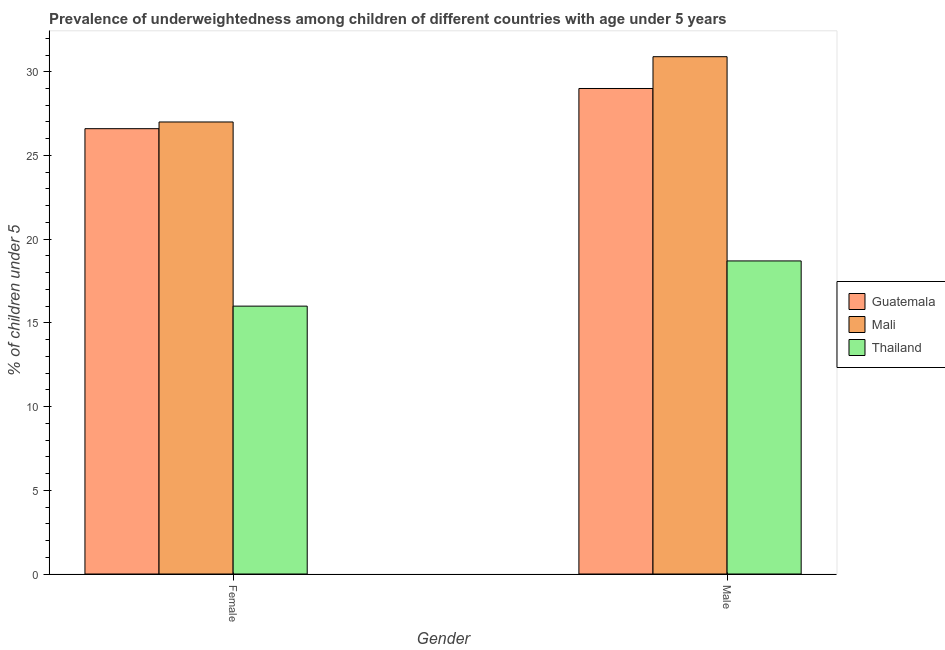How many different coloured bars are there?
Offer a terse response. 3. How many bars are there on the 1st tick from the left?
Provide a short and direct response. 3. How many bars are there on the 1st tick from the right?
Your answer should be very brief. 3. What is the label of the 2nd group of bars from the left?
Keep it short and to the point. Male. What is the percentage of underweighted female children in Mali?
Keep it short and to the point. 27. Across all countries, what is the minimum percentage of underweighted male children?
Keep it short and to the point. 18.7. In which country was the percentage of underweighted female children maximum?
Keep it short and to the point. Mali. In which country was the percentage of underweighted male children minimum?
Give a very brief answer. Thailand. What is the total percentage of underweighted male children in the graph?
Offer a very short reply. 78.6. What is the difference between the percentage of underweighted female children in Thailand and that in Guatemala?
Keep it short and to the point. -10.6. What is the difference between the percentage of underweighted male children in Thailand and the percentage of underweighted female children in Guatemala?
Your answer should be compact. -7.9. What is the average percentage of underweighted female children per country?
Your answer should be very brief. 23.2. What is the difference between the percentage of underweighted male children and percentage of underweighted female children in Mali?
Your answer should be very brief. 3.9. In how many countries, is the percentage of underweighted female children greater than 8 %?
Offer a very short reply. 3. What is the ratio of the percentage of underweighted male children in Mali to that in Guatemala?
Offer a very short reply. 1.07. Is the percentage of underweighted male children in Guatemala less than that in Mali?
Give a very brief answer. Yes. In how many countries, is the percentage of underweighted male children greater than the average percentage of underweighted male children taken over all countries?
Make the answer very short. 2. What does the 2nd bar from the left in Female represents?
Offer a terse response. Mali. What does the 1st bar from the right in Male represents?
Provide a succinct answer. Thailand. How many bars are there?
Your answer should be very brief. 6. How many countries are there in the graph?
Keep it short and to the point. 3. Are the values on the major ticks of Y-axis written in scientific E-notation?
Give a very brief answer. No. Does the graph contain grids?
Your response must be concise. No. Where does the legend appear in the graph?
Provide a succinct answer. Center right. What is the title of the graph?
Your answer should be very brief. Prevalence of underweightedness among children of different countries with age under 5 years. What is the label or title of the Y-axis?
Provide a succinct answer.  % of children under 5. What is the  % of children under 5 in Guatemala in Female?
Make the answer very short. 26.6. What is the  % of children under 5 in Mali in Female?
Your answer should be compact. 27. What is the  % of children under 5 of Thailand in Female?
Keep it short and to the point. 16. What is the  % of children under 5 of Guatemala in Male?
Offer a terse response. 29. What is the  % of children under 5 of Mali in Male?
Provide a short and direct response. 30.9. What is the  % of children under 5 of Thailand in Male?
Your response must be concise. 18.7. Across all Gender, what is the maximum  % of children under 5 in Mali?
Keep it short and to the point. 30.9. Across all Gender, what is the maximum  % of children under 5 of Thailand?
Provide a succinct answer. 18.7. Across all Gender, what is the minimum  % of children under 5 in Guatemala?
Offer a very short reply. 26.6. What is the total  % of children under 5 of Guatemala in the graph?
Offer a very short reply. 55.6. What is the total  % of children under 5 of Mali in the graph?
Offer a very short reply. 57.9. What is the total  % of children under 5 of Thailand in the graph?
Provide a short and direct response. 34.7. What is the difference between the  % of children under 5 of Guatemala in Female and that in Male?
Offer a terse response. -2.4. What is the difference between the  % of children under 5 in Thailand in Female and that in Male?
Make the answer very short. -2.7. What is the average  % of children under 5 in Guatemala per Gender?
Your response must be concise. 27.8. What is the average  % of children under 5 in Mali per Gender?
Provide a short and direct response. 28.95. What is the average  % of children under 5 of Thailand per Gender?
Make the answer very short. 17.35. What is the difference between the  % of children under 5 of Guatemala and  % of children under 5 of Mali in Female?
Your response must be concise. -0.4. What is the difference between the  % of children under 5 in Guatemala and  % of children under 5 in Thailand in Female?
Your response must be concise. 10.6. What is the difference between the  % of children under 5 in Mali and  % of children under 5 in Thailand in Female?
Your answer should be compact. 11. What is the difference between the  % of children under 5 of Guatemala and  % of children under 5 of Thailand in Male?
Give a very brief answer. 10.3. What is the ratio of the  % of children under 5 of Guatemala in Female to that in Male?
Provide a succinct answer. 0.92. What is the ratio of the  % of children under 5 in Mali in Female to that in Male?
Your answer should be compact. 0.87. What is the ratio of the  % of children under 5 of Thailand in Female to that in Male?
Give a very brief answer. 0.86. What is the difference between the highest and the second highest  % of children under 5 of Guatemala?
Your answer should be very brief. 2.4. What is the difference between the highest and the second highest  % of children under 5 in Mali?
Keep it short and to the point. 3.9. 